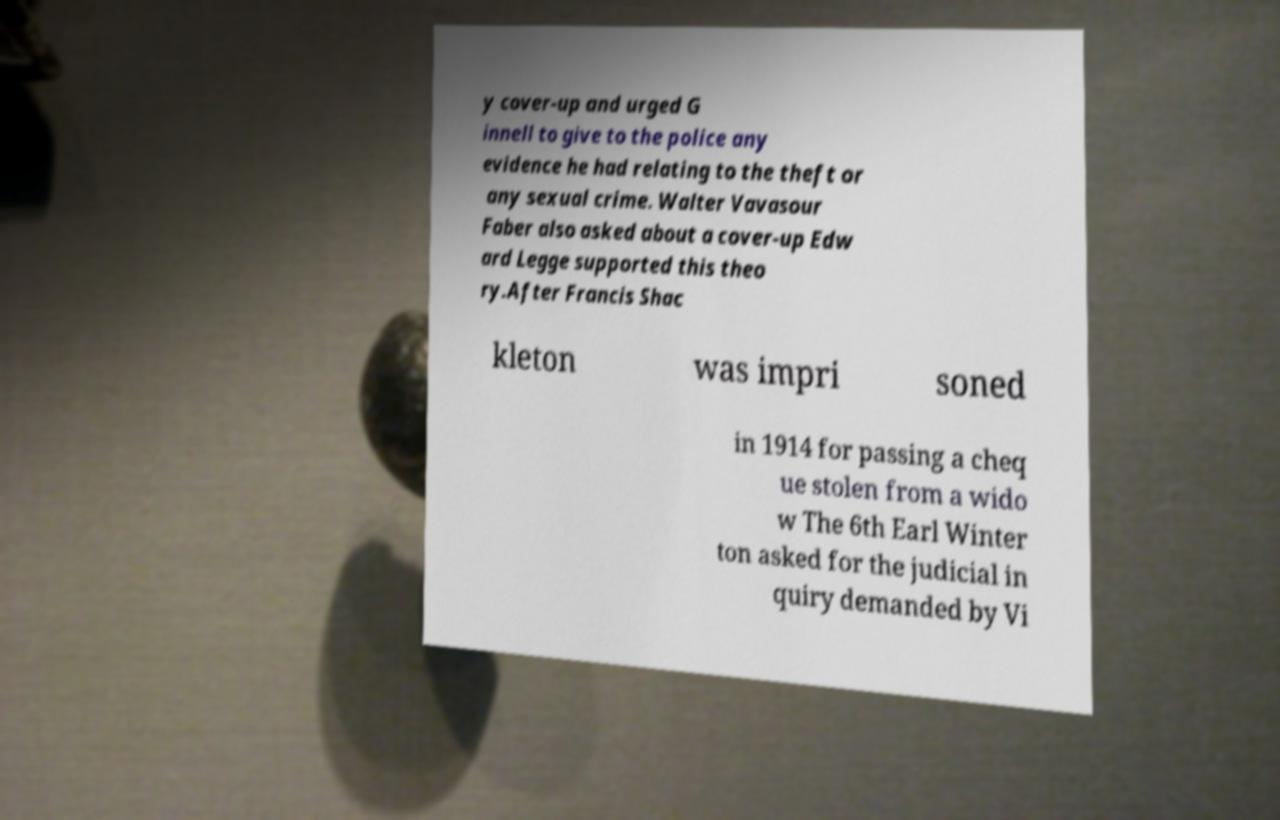Please read and relay the text visible in this image. What does it say? y cover-up and urged G innell to give to the police any evidence he had relating to the theft or any sexual crime. Walter Vavasour Faber also asked about a cover-up Edw ard Legge supported this theo ry.After Francis Shac kleton was impri soned in 1914 for passing a cheq ue stolen from a wido w The 6th Earl Winter ton asked for the judicial in quiry demanded by Vi 